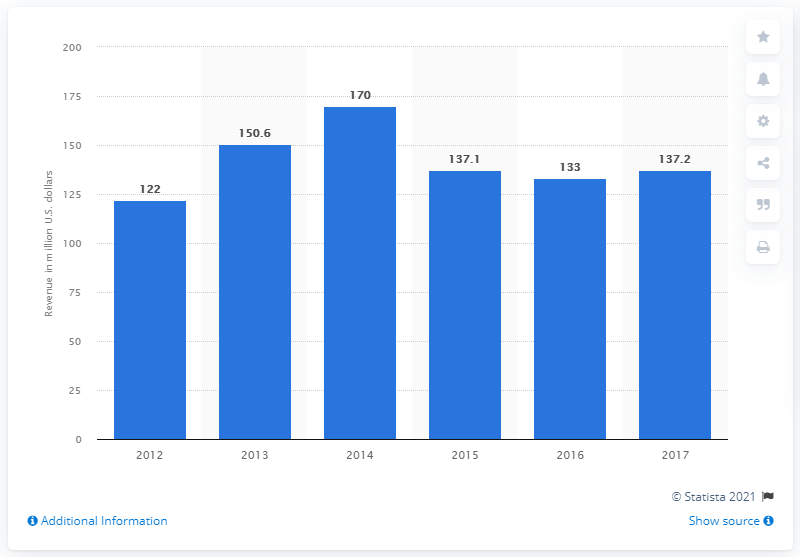Draw attention to some important aspects in this diagram. The revenue of the Bodytech Brazil company in 2017 was R$137,200,000. 